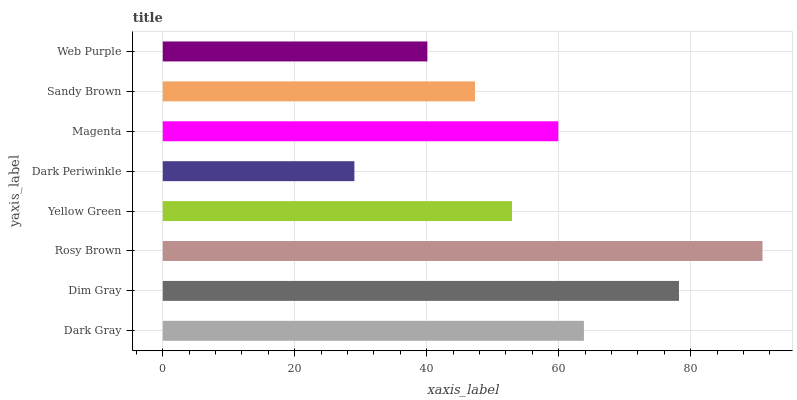Is Dark Periwinkle the minimum?
Answer yes or no. Yes. Is Rosy Brown the maximum?
Answer yes or no. Yes. Is Dim Gray the minimum?
Answer yes or no. No. Is Dim Gray the maximum?
Answer yes or no. No. Is Dim Gray greater than Dark Gray?
Answer yes or no. Yes. Is Dark Gray less than Dim Gray?
Answer yes or no. Yes. Is Dark Gray greater than Dim Gray?
Answer yes or no. No. Is Dim Gray less than Dark Gray?
Answer yes or no. No. Is Magenta the high median?
Answer yes or no. Yes. Is Yellow Green the low median?
Answer yes or no. Yes. Is Dark Gray the high median?
Answer yes or no. No. Is Magenta the low median?
Answer yes or no. No. 